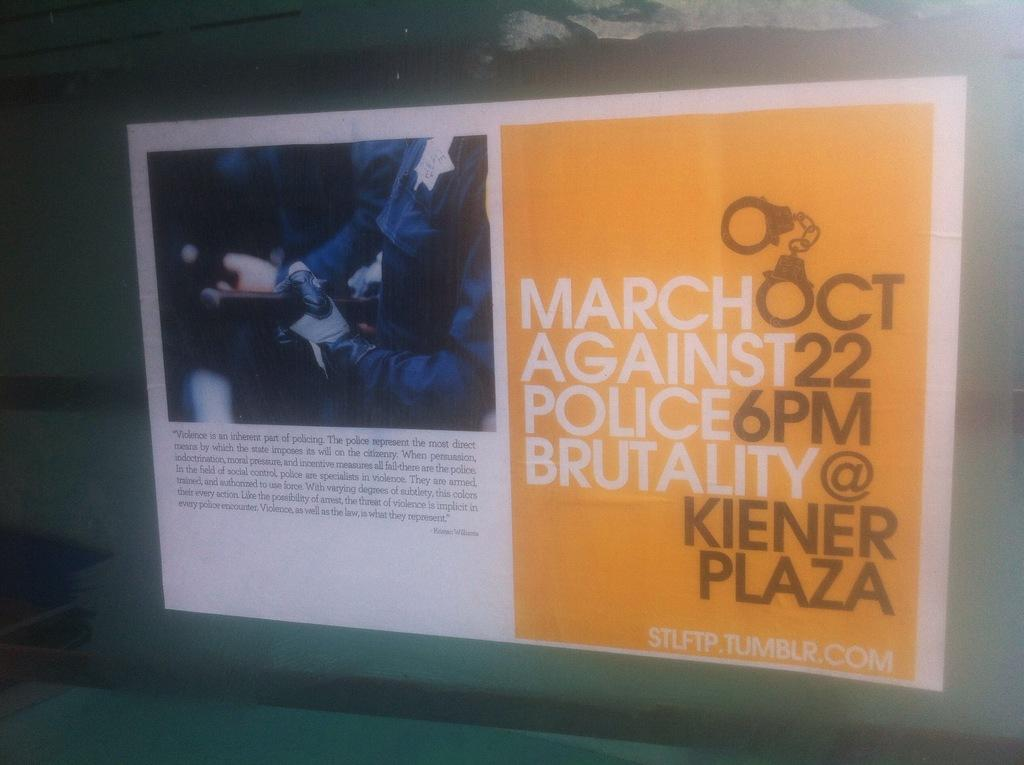What is on the wall in the image? There is a projector screen on the wall. What can be seen on the projector screen? There is text and a picture of a person on the screen. What type of straw is the person holding in the image? There is no straw present in the image; the person is depicted in a picture on the projector screen. 